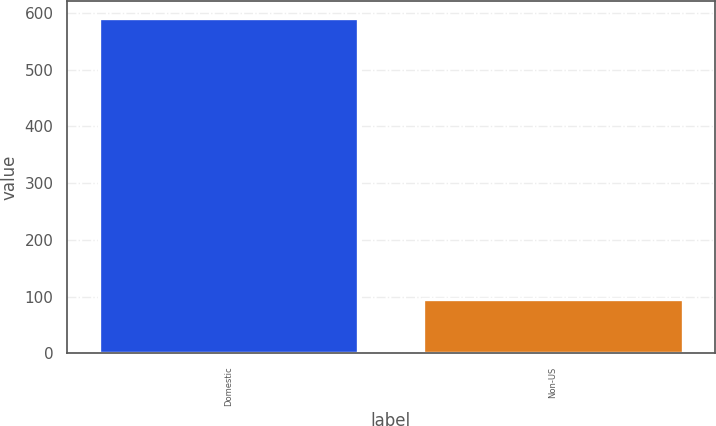Convert chart. <chart><loc_0><loc_0><loc_500><loc_500><bar_chart><fcel>Domestic<fcel>Non-US<nl><fcel>591.8<fcel>95.9<nl></chart> 